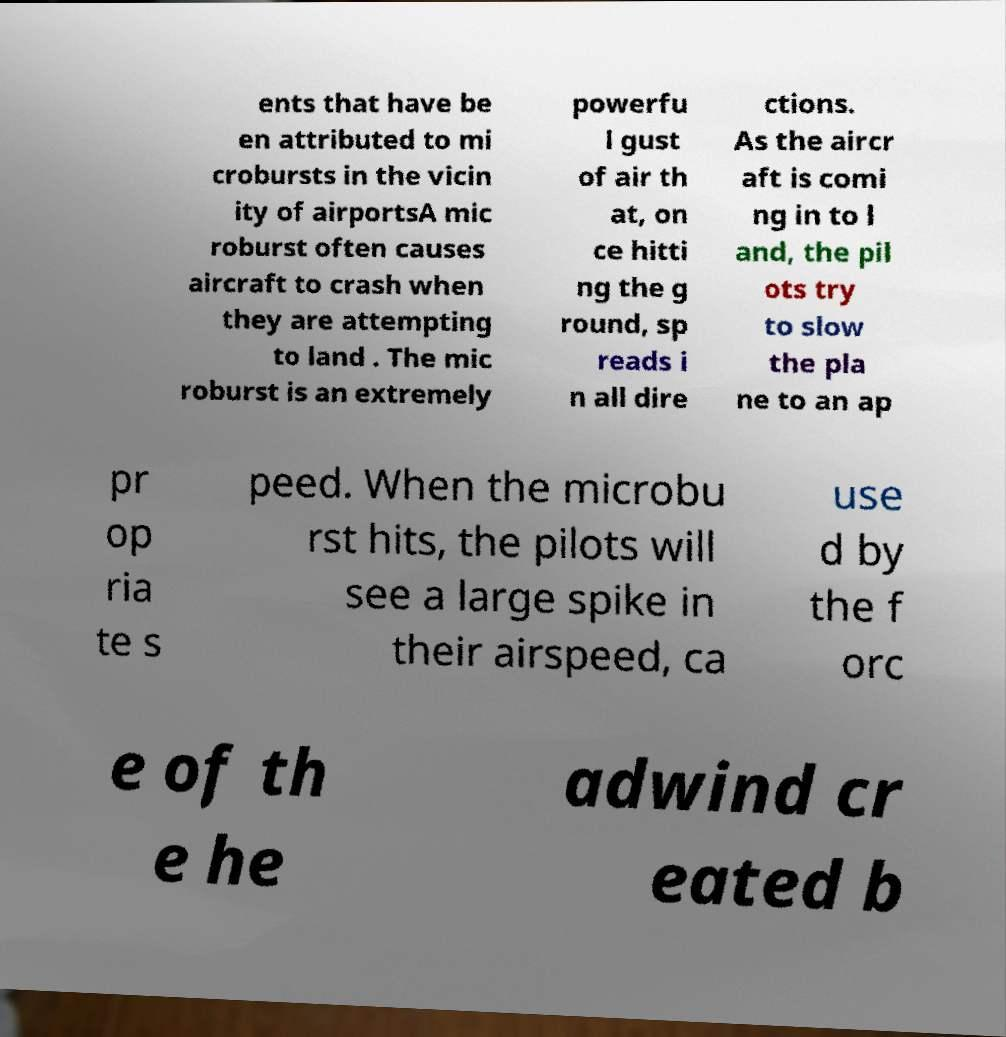There's text embedded in this image that I need extracted. Can you transcribe it verbatim? ents that have be en attributed to mi crobursts in the vicin ity of airportsA mic roburst often causes aircraft to crash when they are attempting to land . The mic roburst is an extremely powerfu l gust of air th at, on ce hitti ng the g round, sp reads i n all dire ctions. As the aircr aft is comi ng in to l and, the pil ots try to slow the pla ne to an ap pr op ria te s peed. When the microbu rst hits, the pilots will see a large spike in their airspeed, ca use d by the f orc e of th e he adwind cr eated b 